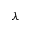Convert formula to latex. <formula><loc_0><loc_0><loc_500><loc_500>\lambda</formula> 